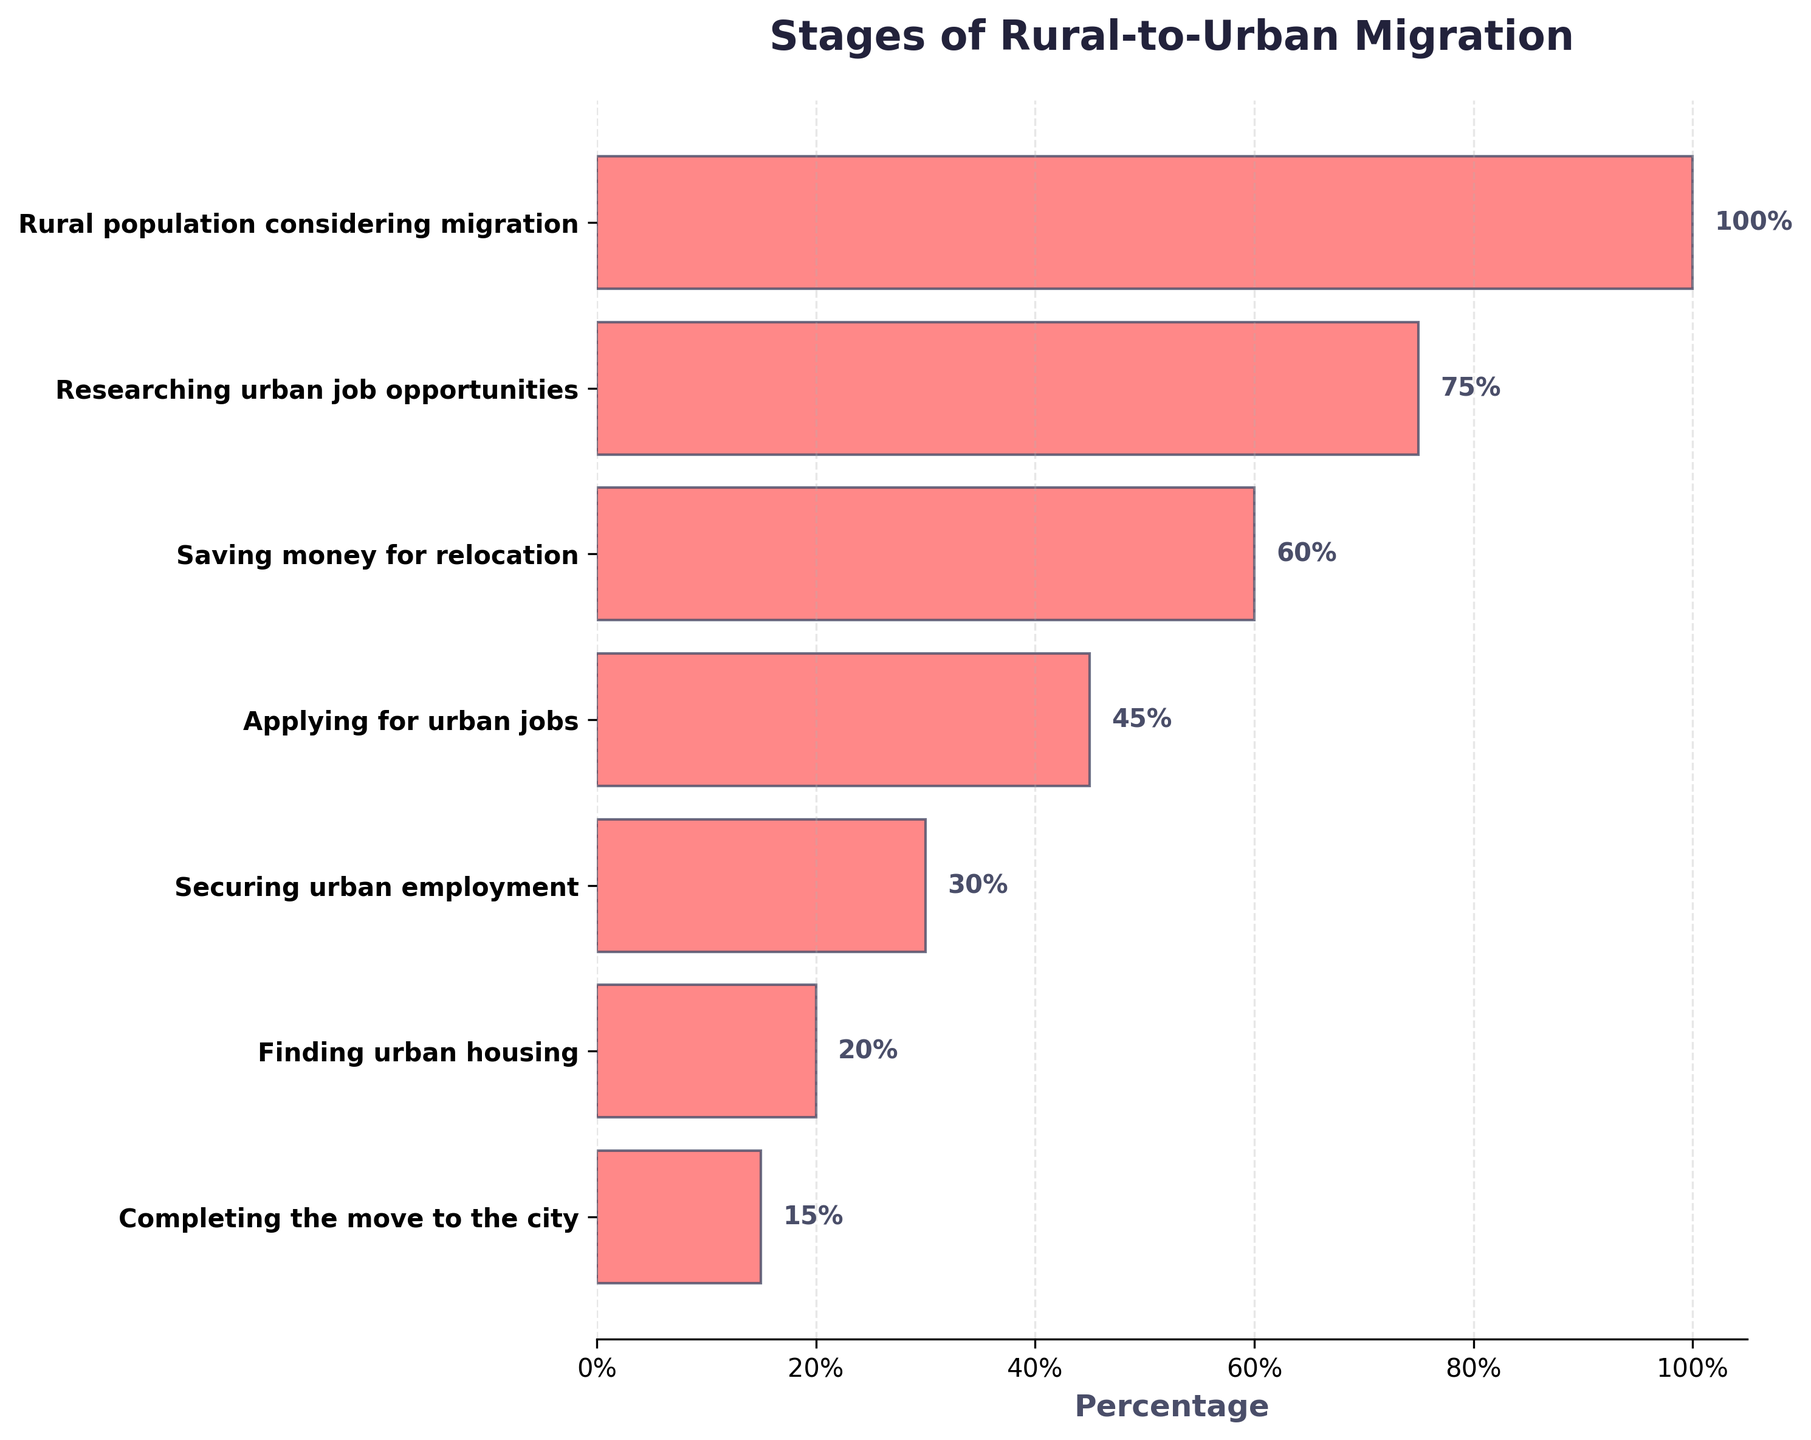What is the title of the figure? The title is displayed at the top of the figure and it reads "Stages of Rural-to-Urban Migration".
Answer: Stages of Rural-to-Urban Migration What stage has the highest percentage of people? The stage with the highest percentage of people is the first one at the top of the funnel, which is "Rural population considering migration" with 100%.
Answer: Rural population considering migration Which stage has the smallest percentage of completion? The stage with the smallest percentage is "Completing the move to the city" at the bottom of the funnel with 15%.
Answer: Completing the move to the city By what percentage does the number of people decrease from "Researching urban job opportunities" to "Saving money for relocation"? Subtract the percentage of "Saving money for relocation" (60%) from "Researching urban job opportunities" (75%). The decrease is \(75\% - 60\% = 15\%\).
Answer: 15% Which stages have a percentage below 50%? The stages below 50% are "Applying for urban jobs" (45%), "Securing urban employment" (30%), "Finding urban housing" (20%), and "Completing the move to the city" (15%).
Answer: Applying for urban jobs, Securing urban employment, Finding urban housing, Completing the move to the city How many stages are represented in the funnel chart? Counting all the stages listed along the y-axis, there are 7 stages.
Answer: 7 By how much does the percentage drop from securing urban employment to finding urban housing? The percentage drops from "Securing urban employment" (30%) to "Finding urban housing" (20%), so \(30\% - 20\% = 10\%\).
Answer: 10% What is the difference in percentage between the first and last stages? Subtract the percentage of "Completing the move to the city" (15%) from "Rural population considering migration" (100%). The difference is \(100\% - 15\% = 85\%\).
Answer: 85% Which two stages have the largest gap in percentage? The largest gap is between "Rural population considering migration" (100%) and "Researching urban job opportunities" (75%), which is \(100\% - 75\% = 25\%\).
Answer: Rural population considering migration and Researching urban job opportunities What percentage of the rural population completes the move to the city? According to the figure, 15% of the rural population completes the move to the city.
Answer: 15% 